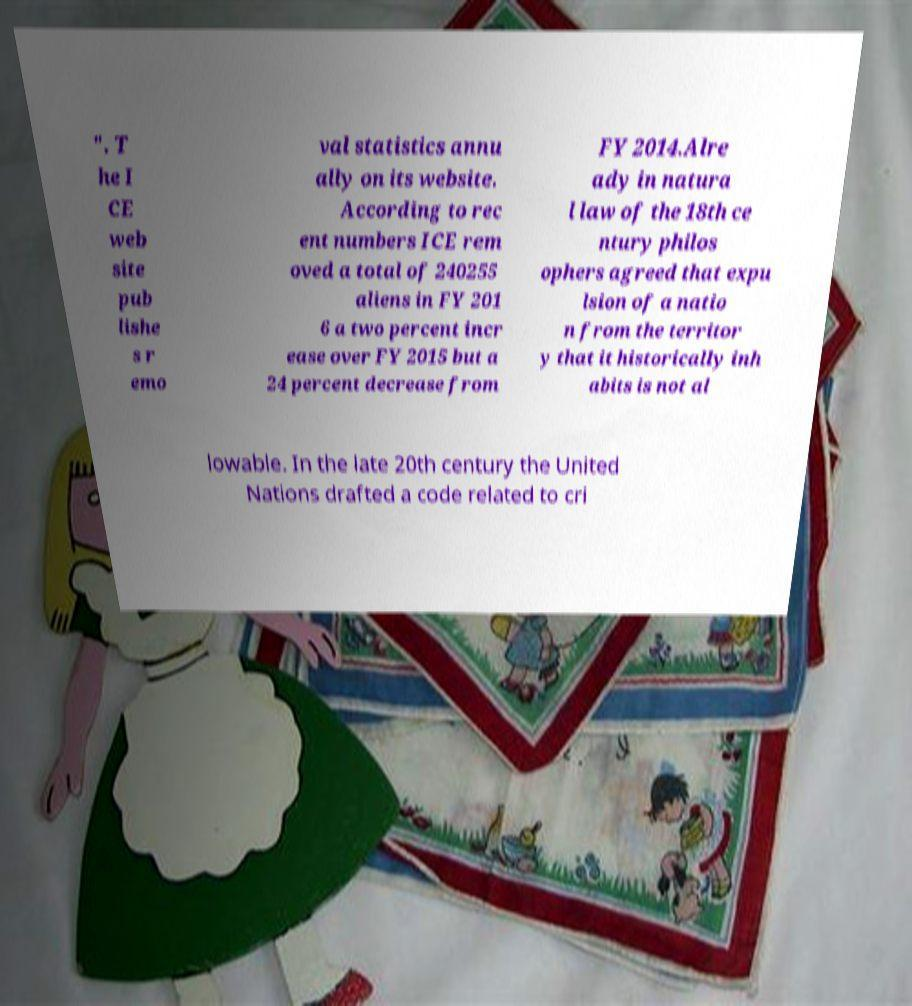Can you read and provide the text displayed in the image?This photo seems to have some interesting text. Can you extract and type it out for me? ". T he I CE web site pub lishe s r emo val statistics annu ally on its website. According to rec ent numbers ICE rem oved a total of 240255 aliens in FY 201 6 a two percent incr ease over FY 2015 but a 24 percent decrease from FY 2014.Alre ady in natura l law of the 18th ce ntury philos ophers agreed that expu lsion of a natio n from the territor y that it historically inh abits is not al lowable. In the late 20th century the United Nations drafted a code related to cri 